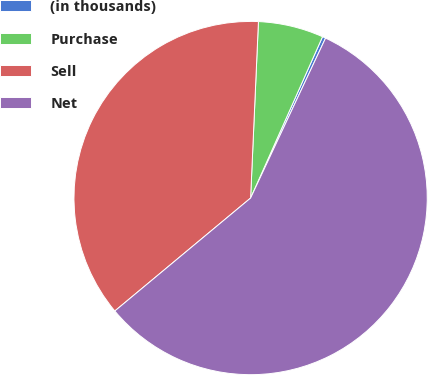Convert chart to OTSL. <chart><loc_0><loc_0><loc_500><loc_500><pie_chart><fcel>(in thousands)<fcel>Purchase<fcel>Sell<fcel>Net<nl><fcel>0.3%<fcel>5.97%<fcel>36.75%<fcel>56.98%<nl></chart> 